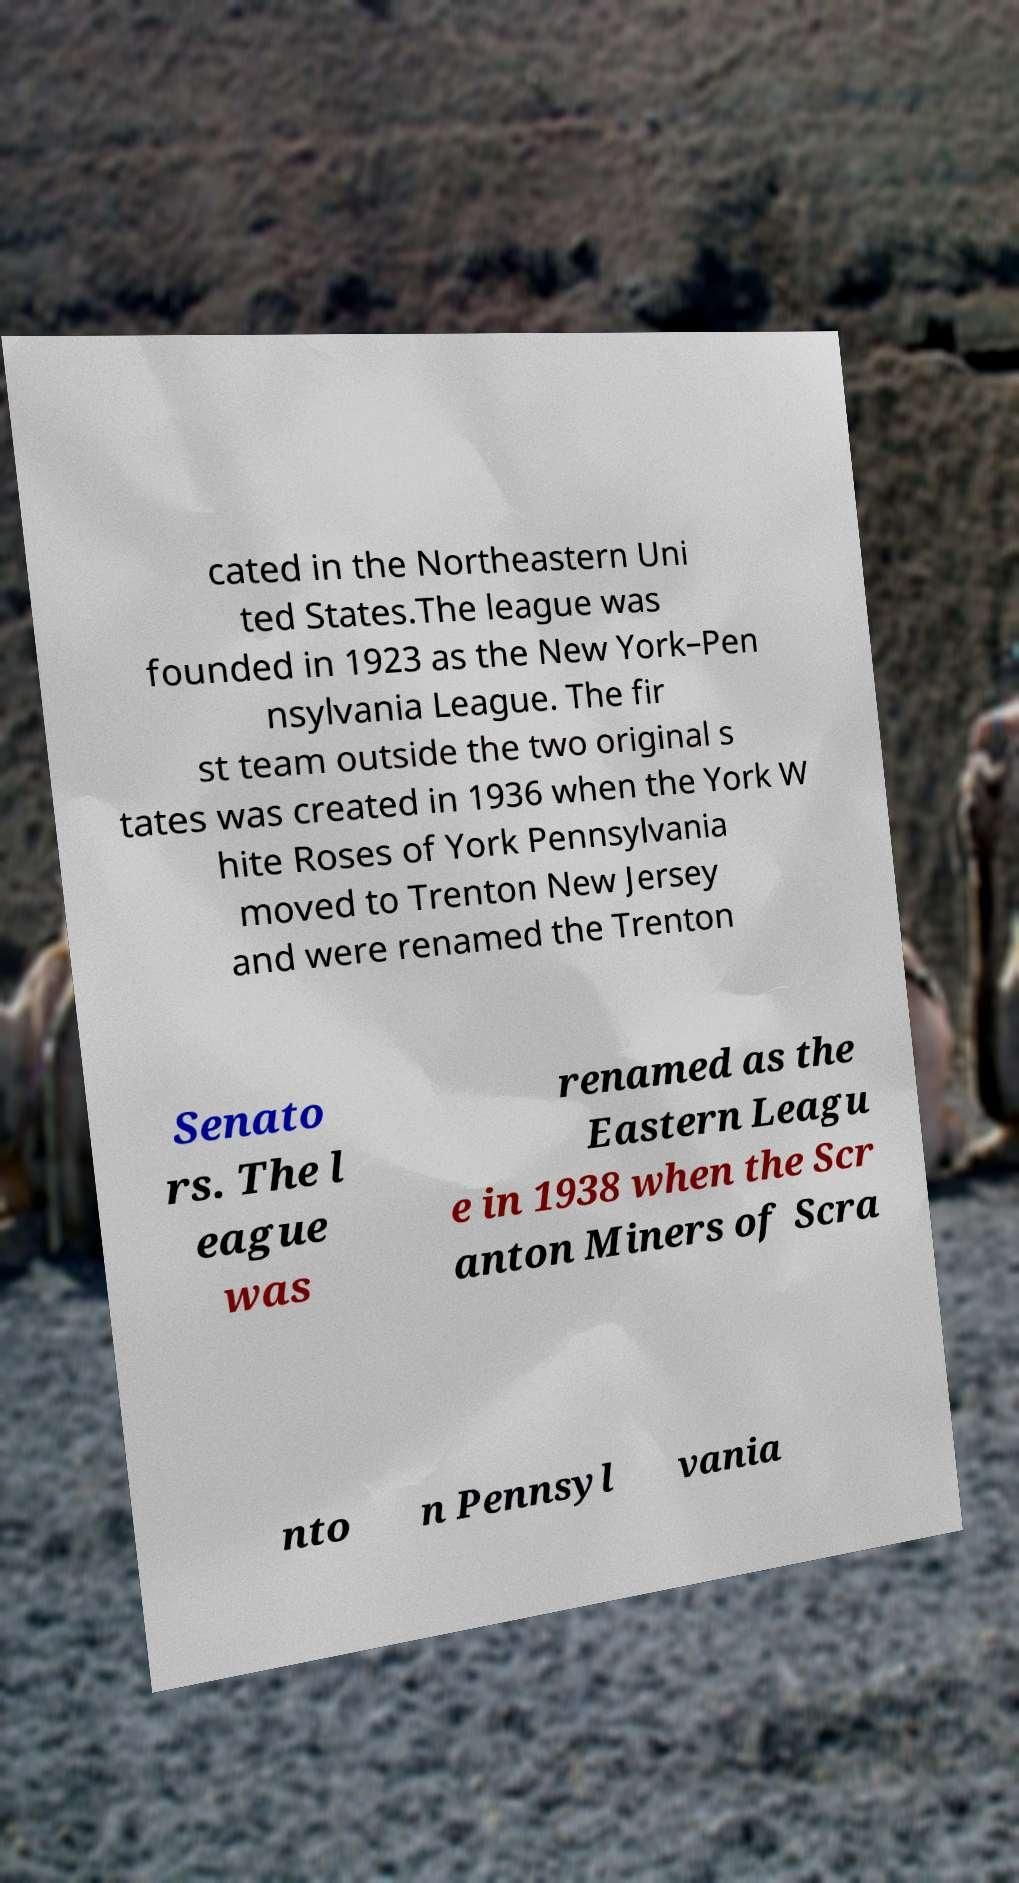Can you read and provide the text displayed in the image?This photo seems to have some interesting text. Can you extract and type it out for me? cated in the Northeastern Uni ted States.The league was founded in 1923 as the New York–Pen nsylvania League. The fir st team outside the two original s tates was created in 1936 when the York W hite Roses of York Pennsylvania moved to Trenton New Jersey and were renamed the Trenton Senato rs. The l eague was renamed as the Eastern Leagu e in 1938 when the Scr anton Miners of Scra nto n Pennsyl vania 